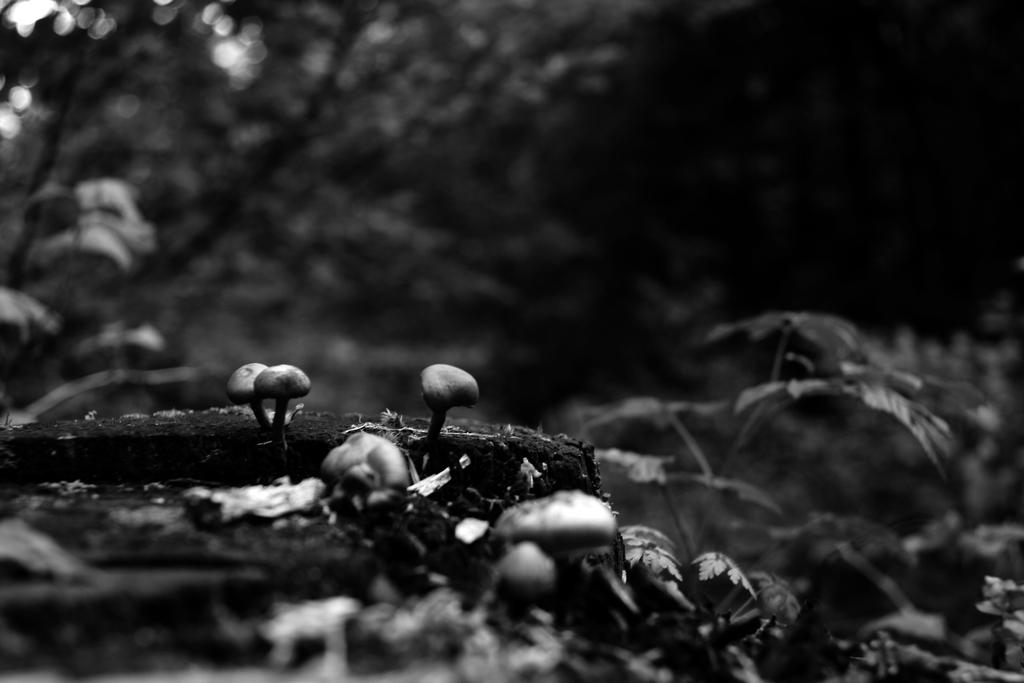What is the color scheme of the image? The image is black and white. What can be seen on the ground in the image? There are mushrooms on the ground. What type of vegetation is visible in the background of the image? There are trees with green leaves in the background. What type of drug is being used by the person in the image? There is no person present in the image, and therefore no drug use can be observed. 